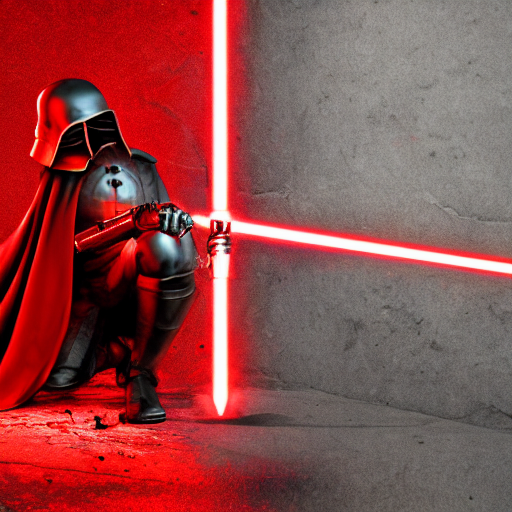What can you infer about the character from the red lightsaber and the outfit? The red lightsaber, along with the dark cloak and helmet, suggest that the character is often associated with the archetype of a villain in popular culture, hinting at darkness or malevolence. 